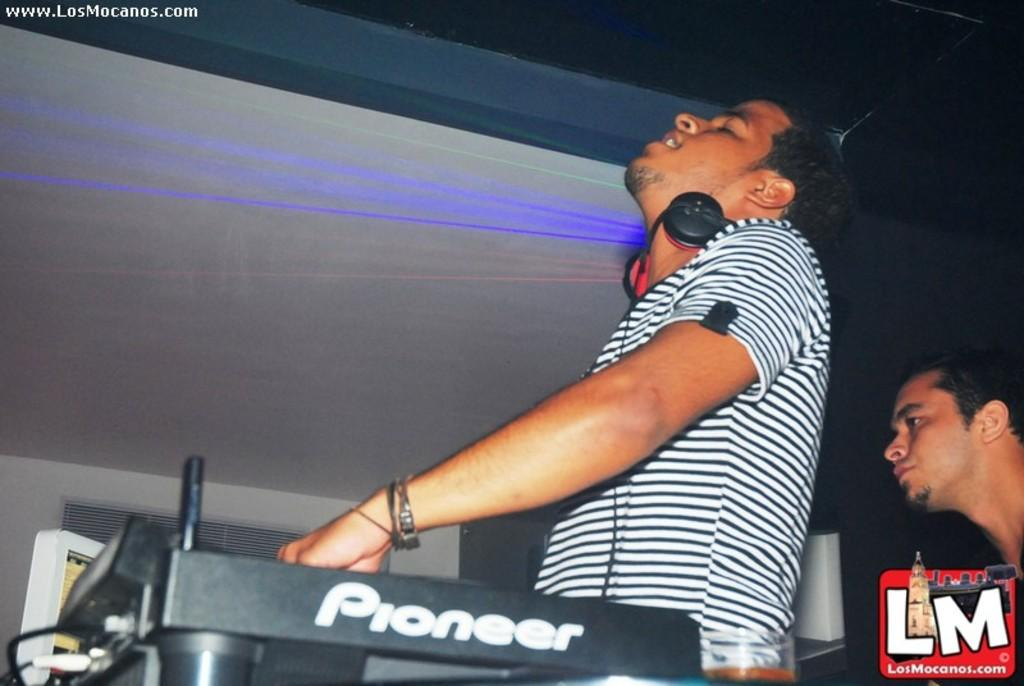What is the man in the middle of the image doing? The man in the middle of the image is adjusting a music system. What is the man on the right side of the image doing? The man on the right side of the image is looking at that side. What is the man in the middle of the image wearing? The man in the middle of the image is wearing a t-shirt. What type of sign can be seen in the image? There is no sign present in the image. How many dolls are visible in the image? There are no dolls present in the image. 